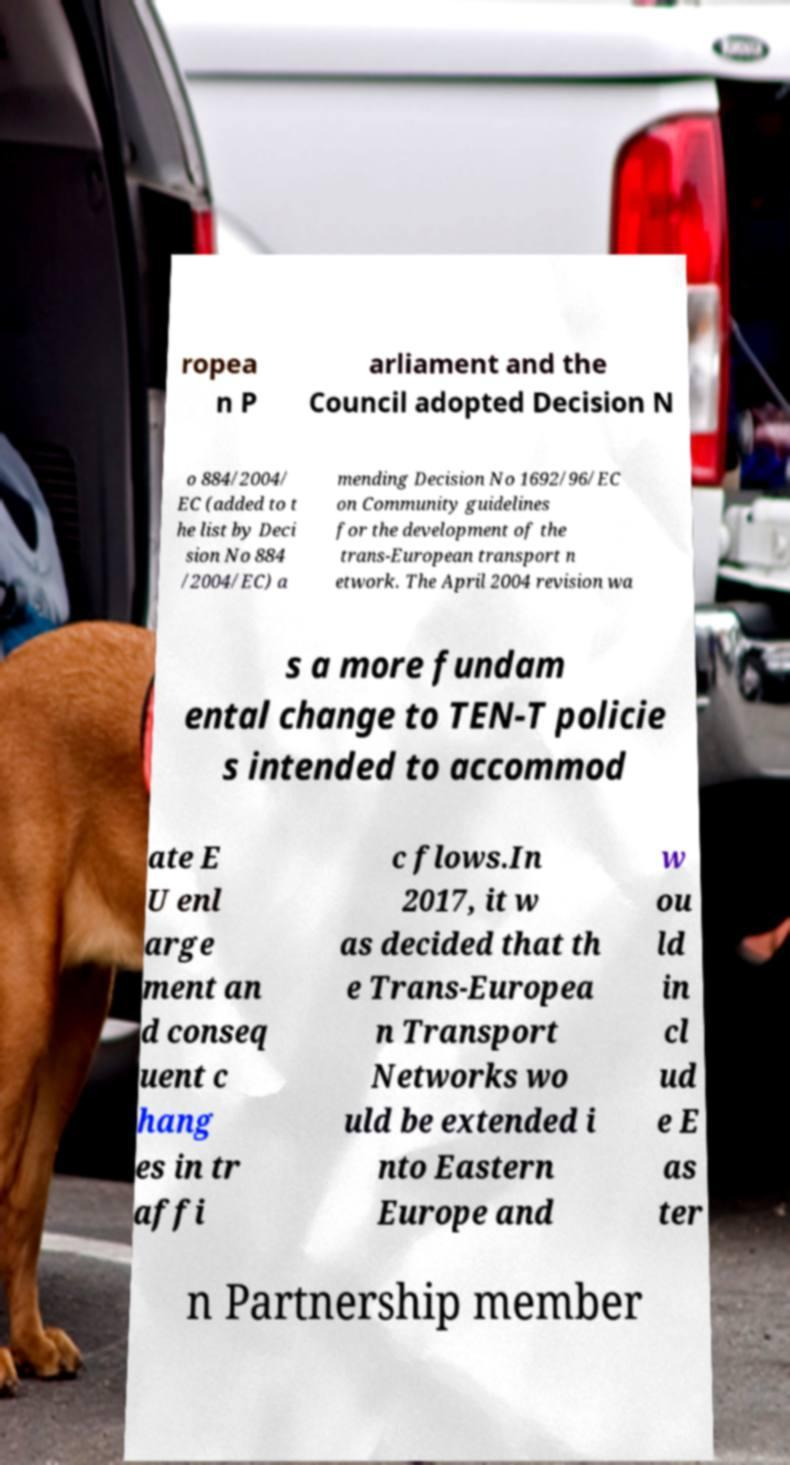Can you accurately transcribe the text from the provided image for me? ropea n P arliament and the Council adopted Decision N o 884/2004/ EC (added to t he list by Deci sion No 884 /2004/EC) a mending Decision No 1692/96/EC on Community guidelines for the development of the trans-European transport n etwork. The April 2004 revision wa s a more fundam ental change to TEN-T policie s intended to accommod ate E U enl arge ment an d conseq uent c hang es in tr affi c flows.In 2017, it w as decided that th e Trans-Europea n Transport Networks wo uld be extended i nto Eastern Europe and w ou ld in cl ud e E as ter n Partnership member 